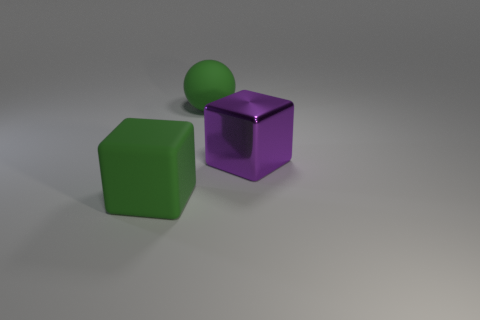Add 2 big rubber blocks. How many objects exist? 5 Subtract all balls. How many objects are left? 2 Add 1 big rubber balls. How many big rubber balls are left? 2 Add 3 yellow matte cylinders. How many yellow matte cylinders exist? 3 Subtract 0 brown blocks. How many objects are left? 3 Subtract all big gray rubber things. Subtract all big green objects. How many objects are left? 1 